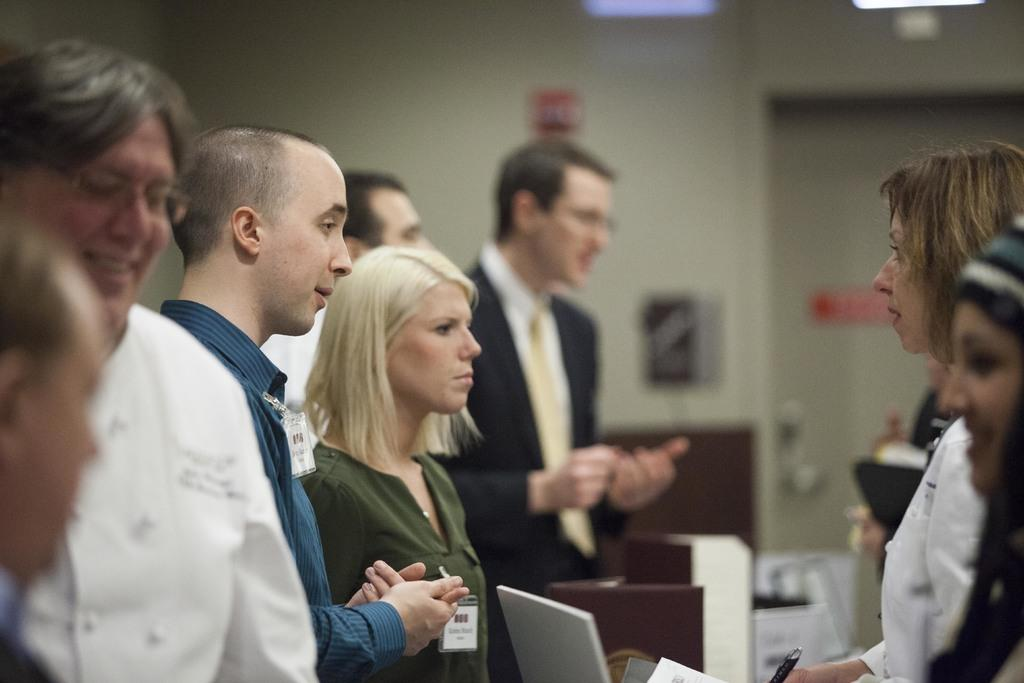How many people are in the room? There are people in the room, but the exact number is not specified. What electronic device can be seen in the room? There is a laptop in the room. What else is present in the room besides people and the laptop? There are objects in the room, but their specific nature is not mentioned. What decorations are on the wall in the room? There are posters attached to the wall. How can one enter or exit the room? There is a door in the room. What type of neck pillow is on the floor in the image? There is no neck pillow present in the image. What is the color of the bottle on the desk in the image? There is no bottle present in the image. 